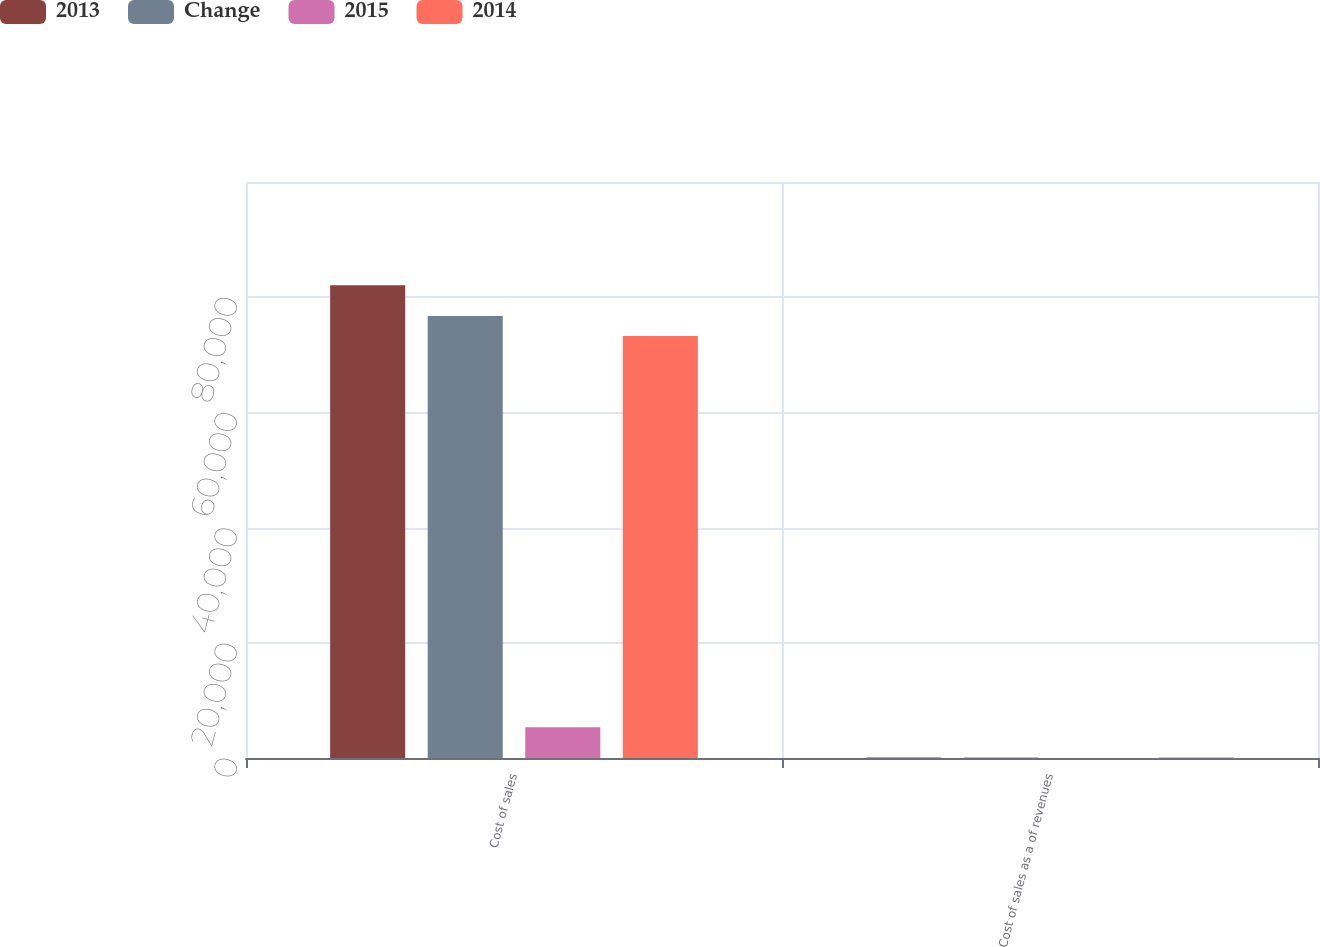Convert chart to OTSL. <chart><loc_0><loc_0><loc_500><loc_500><stacked_bar_chart><ecel><fcel>Cost of sales<fcel>Cost of sales as a of revenues<nl><fcel>2013<fcel>82088<fcel>85.4<nl><fcel>Change<fcel>76752<fcel>84.6<nl><fcel>2015<fcel>5336<fcel>0.8<nl><fcel>2014<fcel>73268<fcel>84.6<nl></chart> 